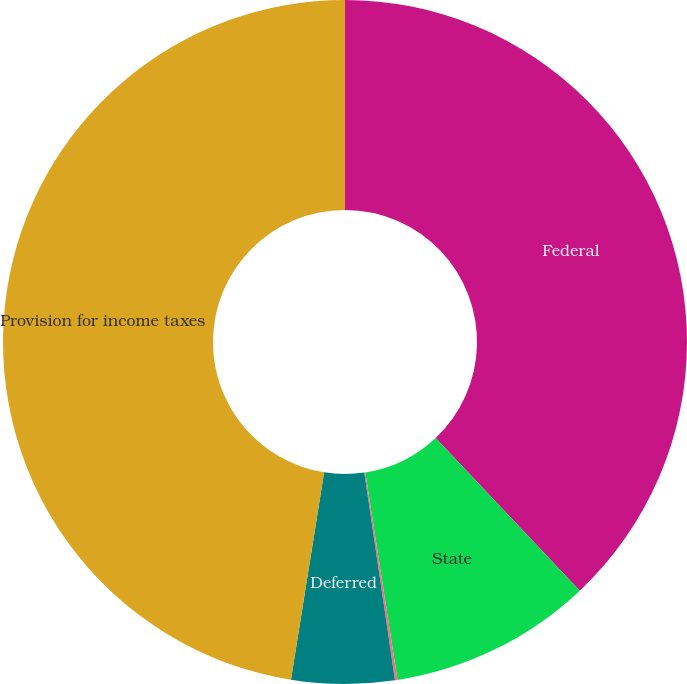<chart> <loc_0><loc_0><loc_500><loc_500><pie_chart><fcel>Federal<fcel>State<fcel>Foreign<fcel>Deferred<fcel>Provision for income taxes<nl><fcel>37.95%<fcel>9.59%<fcel>0.12%<fcel>4.86%<fcel>47.47%<nl></chart> 